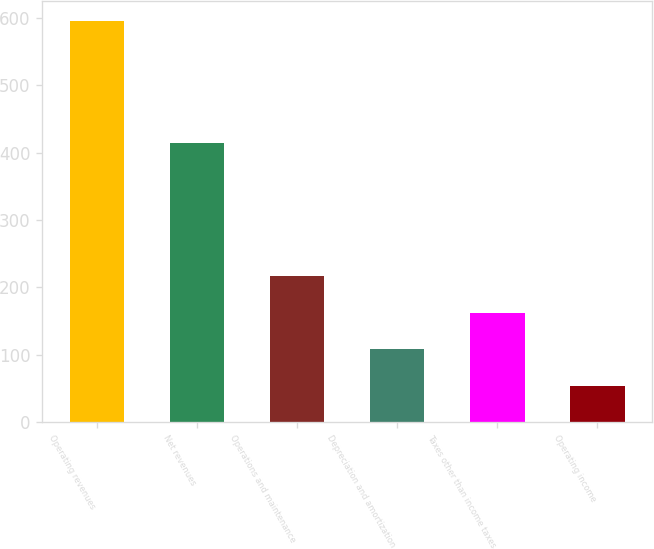<chart> <loc_0><loc_0><loc_500><loc_500><bar_chart><fcel>Operating revenues<fcel>Net revenues<fcel>Operations and maintenance<fcel>Depreciation and amortization<fcel>Taxes other than income taxes<fcel>Operating income<nl><fcel>596<fcel>415<fcel>216.6<fcel>108.2<fcel>162.4<fcel>54<nl></chart> 